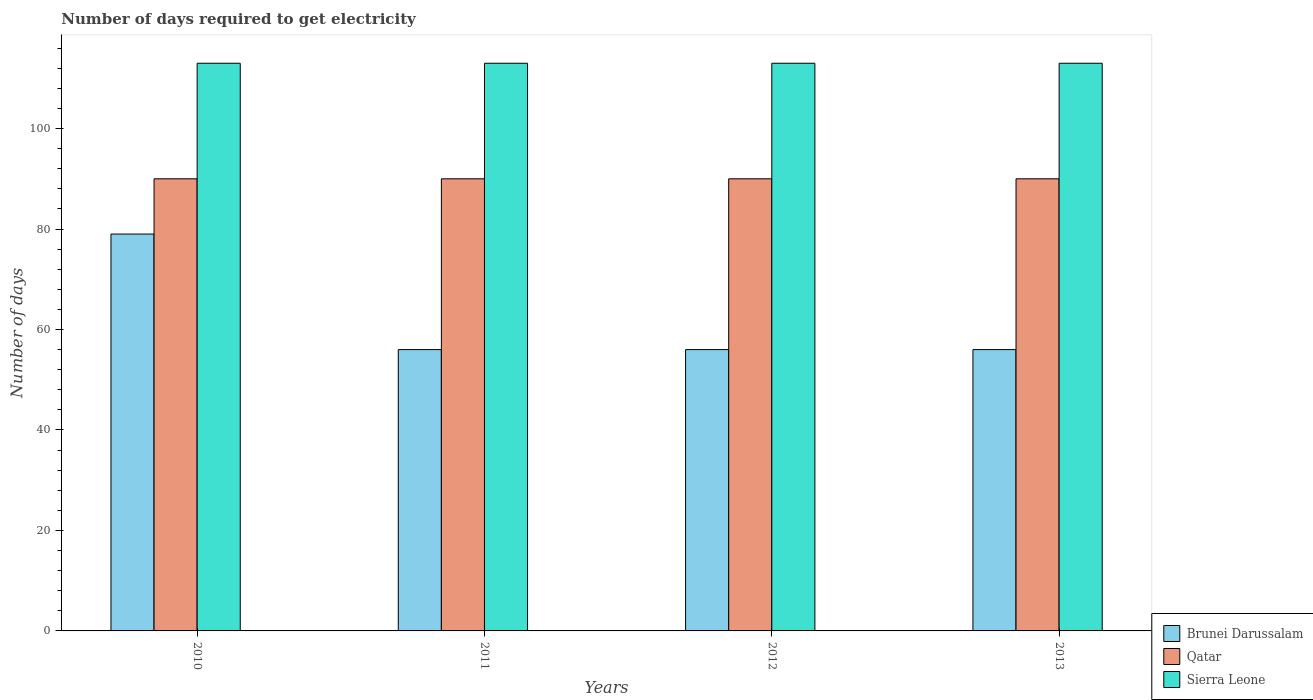How many groups of bars are there?
Offer a terse response. 4. Are the number of bars per tick equal to the number of legend labels?
Make the answer very short. Yes. How many bars are there on the 1st tick from the left?
Offer a terse response. 3. What is the label of the 4th group of bars from the left?
Ensure brevity in your answer.  2013. What is the number of days required to get electricity in in Brunei Darussalam in 2013?
Your answer should be compact. 56. Across all years, what is the maximum number of days required to get electricity in in Brunei Darussalam?
Provide a succinct answer. 79. Across all years, what is the minimum number of days required to get electricity in in Brunei Darussalam?
Your answer should be very brief. 56. What is the total number of days required to get electricity in in Qatar in the graph?
Your answer should be very brief. 360. What is the difference between the number of days required to get electricity in in Qatar in 2011 and that in 2013?
Ensure brevity in your answer.  0. What is the difference between the number of days required to get electricity in in Sierra Leone in 2012 and the number of days required to get electricity in in Brunei Darussalam in 2013?
Offer a very short reply. 57. What is the average number of days required to get electricity in in Brunei Darussalam per year?
Ensure brevity in your answer.  61.75. In the year 2011, what is the difference between the number of days required to get electricity in in Qatar and number of days required to get electricity in in Sierra Leone?
Give a very brief answer. -23. In how many years, is the number of days required to get electricity in in Brunei Darussalam greater than 104 days?
Your response must be concise. 0. What is the difference between the highest and the second highest number of days required to get electricity in in Brunei Darussalam?
Provide a short and direct response. 23. What is the difference between the highest and the lowest number of days required to get electricity in in Sierra Leone?
Your response must be concise. 0. In how many years, is the number of days required to get electricity in in Sierra Leone greater than the average number of days required to get electricity in in Sierra Leone taken over all years?
Provide a short and direct response. 0. What does the 1st bar from the left in 2013 represents?
Provide a short and direct response. Brunei Darussalam. What does the 1st bar from the right in 2013 represents?
Your answer should be compact. Sierra Leone. Are all the bars in the graph horizontal?
Ensure brevity in your answer.  No. How many years are there in the graph?
Your answer should be compact. 4. What is the title of the graph?
Keep it short and to the point. Number of days required to get electricity. Does "Australia" appear as one of the legend labels in the graph?
Keep it short and to the point. No. What is the label or title of the Y-axis?
Your answer should be very brief. Number of days. What is the Number of days in Brunei Darussalam in 2010?
Your answer should be very brief. 79. What is the Number of days in Sierra Leone in 2010?
Your answer should be compact. 113. What is the Number of days of Qatar in 2011?
Give a very brief answer. 90. What is the Number of days in Sierra Leone in 2011?
Your answer should be compact. 113. What is the Number of days of Sierra Leone in 2012?
Give a very brief answer. 113. What is the Number of days of Qatar in 2013?
Your response must be concise. 90. What is the Number of days of Sierra Leone in 2013?
Provide a short and direct response. 113. Across all years, what is the maximum Number of days of Brunei Darussalam?
Provide a succinct answer. 79. Across all years, what is the maximum Number of days of Qatar?
Offer a terse response. 90. Across all years, what is the maximum Number of days of Sierra Leone?
Give a very brief answer. 113. Across all years, what is the minimum Number of days in Brunei Darussalam?
Offer a very short reply. 56. Across all years, what is the minimum Number of days in Qatar?
Keep it short and to the point. 90. Across all years, what is the minimum Number of days of Sierra Leone?
Give a very brief answer. 113. What is the total Number of days in Brunei Darussalam in the graph?
Keep it short and to the point. 247. What is the total Number of days in Qatar in the graph?
Your answer should be compact. 360. What is the total Number of days of Sierra Leone in the graph?
Your response must be concise. 452. What is the difference between the Number of days in Sierra Leone in 2010 and that in 2011?
Your answer should be very brief. 0. What is the difference between the Number of days in Brunei Darussalam in 2010 and that in 2012?
Provide a succinct answer. 23. What is the difference between the Number of days of Brunei Darussalam in 2010 and that in 2013?
Keep it short and to the point. 23. What is the difference between the Number of days of Brunei Darussalam in 2011 and that in 2012?
Your answer should be compact. 0. What is the difference between the Number of days of Qatar in 2011 and that in 2012?
Your answer should be compact. 0. What is the difference between the Number of days in Qatar in 2011 and that in 2013?
Give a very brief answer. 0. What is the difference between the Number of days of Sierra Leone in 2011 and that in 2013?
Offer a very short reply. 0. What is the difference between the Number of days of Brunei Darussalam in 2012 and that in 2013?
Offer a terse response. 0. What is the difference between the Number of days of Sierra Leone in 2012 and that in 2013?
Provide a succinct answer. 0. What is the difference between the Number of days of Brunei Darussalam in 2010 and the Number of days of Qatar in 2011?
Ensure brevity in your answer.  -11. What is the difference between the Number of days in Brunei Darussalam in 2010 and the Number of days in Sierra Leone in 2011?
Keep it short and to the point. -34. What is the difference between the Number of days of Brunei Darussalam in 2010 and the Number of days of Qatar in 2012?
Offer a very short reply. -11. What is the difference between the Number of days in Brunei Darussalam in 2010 and the Number of days in Sierra Leone in 2012?
Your response must be concise. -34. What is the difference between the Number of days of Qatar in 2010 and the Number of days of Sierra Leone in 2012?
Offer a terse response. -23. What is the difference between the Number of days of Brunei Darussalam in 2010 and the Number of days of Qatar in 2013?
Your answer should be very brief. -11. What is the difference between the Number of days in Brunei Darussalam in 2010 and the Number of days in Sierra Leone in 2013?
Keep it short and to the point. -34. What is the difference between the Number of days in Qatar in 2010 and the Number of days in Sierra Leone in 2013?
Make the answer very short. -23. What is the difference between the Number of days of Brunei Darussalam in 2011 and the Number of days of Qatar in 2012?
Provide a short and direct response. -34. What is the difference between the Number of days in Brunei Darussalam in 2011 and the Number of days in Sierra Leone in 2012?
Ensure brevity in your answer.  -57. What is the difference between the Number of days in Brunei Darussalam in 2011 and the Number of days in Qatar in 2013?
Your response must be concise. -34. What is the difference between the Number of days of Brunei Darussalam in 2011 and the Number of days of Sierra Leone in 2013?
Offer a terse response. -57. What is the difference between the Number of days of Brunei Darussalam in 2012 and the Number of days of Qatar in 2013?
Keep it short and to the point. -34. What is the difference between the Number of days of Brunei Darussalam in 2012 and the Number of days of Sierra Leone in 2013?
Your answer should be very brief. -57. What is the difference between the Number of days in Qatar in 2012 and the Number of days in Sierra Leone in 2013?
Make the answer very short. -23. What is the average Number of days of Brunei Darussalam per year?
Keep it short and to the point. 61.75. What is the average Number of days of Sierra Leone per year?
Ensure brevity in your answer.  113. In the year 2010, what is the difference between the Number of days in Brunei Darussalam and Number of days in Qatar?
Offer a very short reply. -11. In the year 2010, what is the difference between the Number of days of Brunei Darussalam and Number of days of Sierra Leone?
Your answer should be compact. -34. In the year 2011, what is the difference between the Number of days of Brunei Darussalam and Number of days of Qatar?
Your answer should be very brief. -34. In the year 2011, what is the difference between the Number of days of Brunei Darussalam and Number of days of Sierra Leone?
Offer a terse response. -57. In the year 2012, what is the difference between the Number of days in Brunei Darussalam and Number of days in Qatar?
Your answer should be compact. -34. In the year 2012, what is the difference between the Number of days of Brunei Darussalam and Number of days of Sierra Leone?
Make the answer very short. -57. In the year 2013, what is the difference between the Number of days of Brunei Darussalam and Number of days of Qatar?
Make the answer very short. -34. In the year 2013, what is the difference between the Number of days of Brunei Darussalam and Number of days of Sierra Leone?
Offer a terse response. -57. In the year 2013, what is the difference between the Number of days of Qatar and Number of days of Sierra Leone?
Provide a succinct answer. -23. What is the ratio of the Number of days in Brunei Darussalam in 2010 to that in 2011?
Your answer should be very brief. 1.41. What is the ratio of the Number of days of Brunei Darussalam in 2010 to that in 2012?
Provide a short and direct response. 1.41. What is the ratio of the Number of days of Sierra Leone in 2010 to that in 2012?
Make the answer very short. 1. What is the ratio of the Number of days of Brunei Darussalam in 2010 to that in 2013?
Offer a very short reply. 1.41. What is the ratio of the Number of days of Qatar in 2010 to that in 2013?
Your answer should be compact. 1. What is the ratio of the Number of days in Brunei Darussalam in 2011 to that in 2012?
Keep it short and to the point. 1. What is the ratio of the Number of days in Qatar in 2011 to that in 2012?
Ensure brevity in your answer.  1. What is the ratio of the Number of days of Brunei Darussalam in 2011 to that in 2013?
Ensure brevity in your answer.  1. What is the ratio of the Number of days of Qatar in 2011 to that in 2013?
Offer a very short reply. 1. What is the ratio of the Number of days in Sierra Leone in 2011 to that in 2013?
Make the answer very short. 1. What is the ratio of the Number of days in Brunei Darussalam in 2012 to that in 2013?
Make the answer very short. 1. What is the ratio of the Number of days of Qatar in 2012 to that in 2013?
Keep it short and to the point. 1. What is the difference between the highest and the second highest Number of days of Brunei Darussalam?
Ensure brevity in your answer.  23. What is the difference between the highest and the second highest Number of days in Sierra Leone?
Provide a succinct answer. 0. What is the difference between the highest and the lowest Number of days in Sierra Leone?
Offer a terse response. 0. 